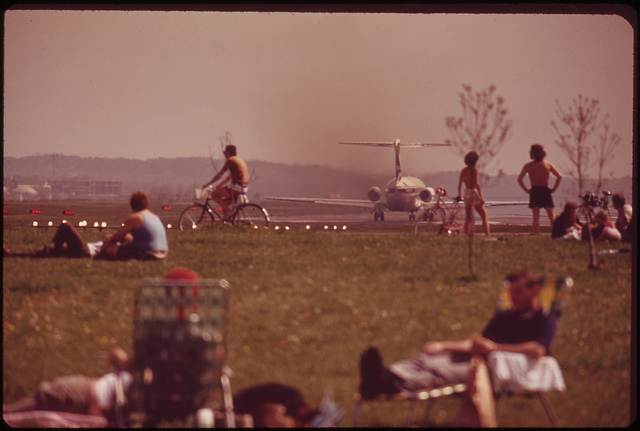<image>What type of sporting event are they attending? It's unclear what type of sporting event they are attending. What type of sporting event are they attending? I am not sure what type of sporting event they are attending. It can be a picnic or a soccer game. 